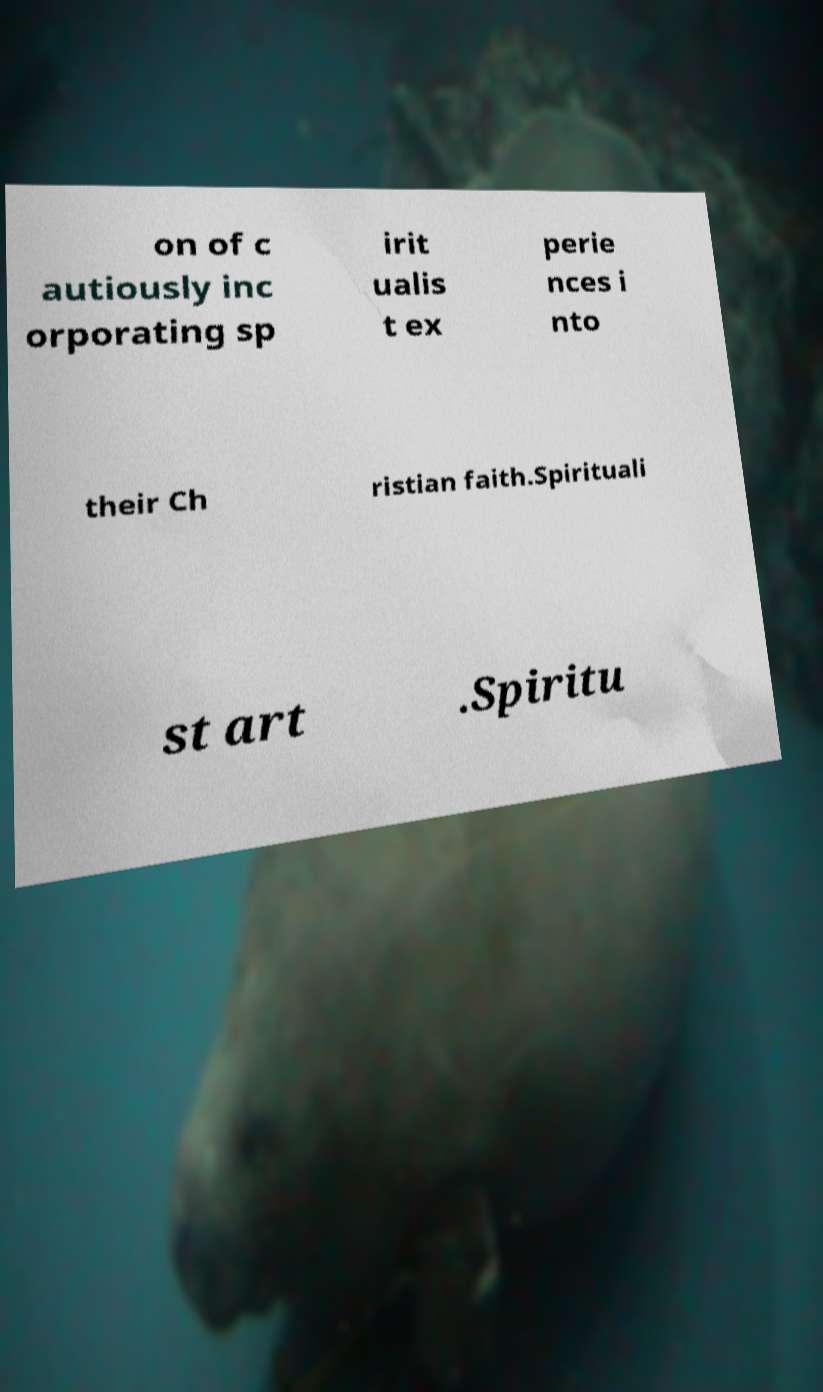What messages or text are displayed in this image? I need them in a readable, typed format. on of c autiously inc orporating sp irit ualis t ex perie nces i nto their Ch ristian faith.Spirituali st art .Spiritu 